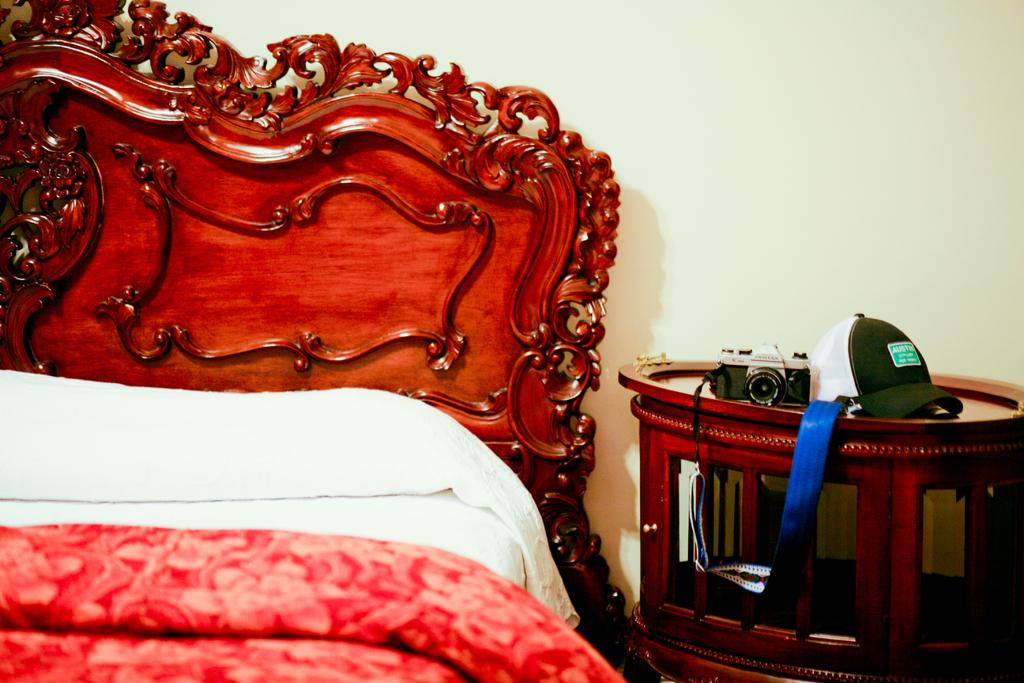What is placed on the table in the image? There is a camera placed on a table. What other object is placed on the table in the image? There is a cap placed on a table. Where is the table located in relation to another piece of furniture? The table is beside a bed. What type of curve can be seen on the horses in the image? There are no horses present in the image, and therefore no curves on horses can be observed. 